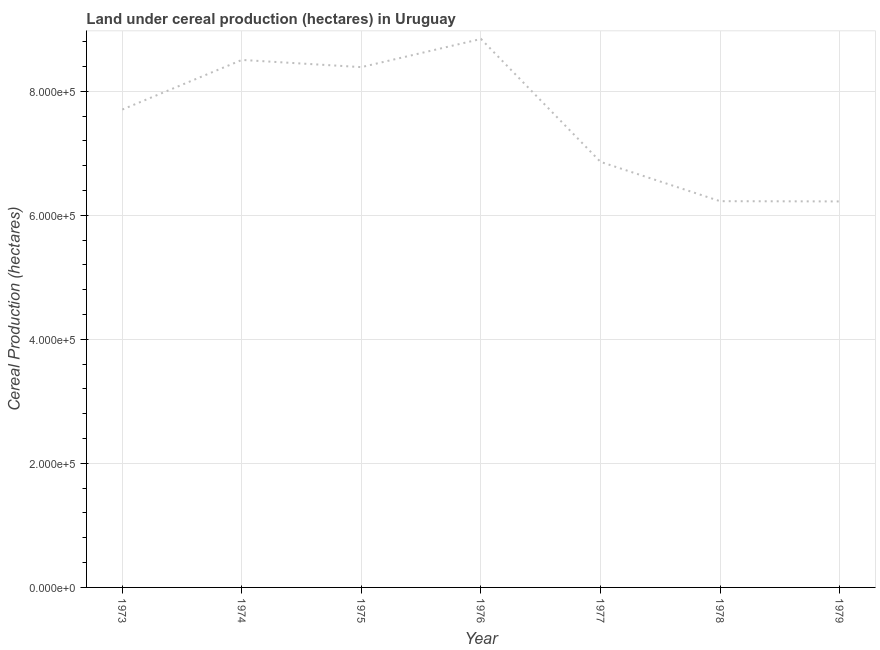What is the land under cereal production in 1979?
Your answer should be compact. 6.22e+05. Across all years, what is the maximum land under cereal production?
Make the answer very short. 8.84e+05. Across all years, what is the minimum land under cereal production?
Make the answer very short. 6.22e+05. In which year was the land under cereal production maximum?
Offer a very short reply. 1976. In which year was the land under cereal production minimum?
Give a very brief answer. 1979. What is the sum of the land under cereal production?
Your answer should be compact. 5.28e+06. What is the difference between the land under cereal production in 1973 and 1976?
Your answer should be very brief. -1.14e+05. What is the average land under cereal production per year?
Your answer should be very brief. 7.54e+05. What is the median land under cereal production?
Offer a terse response. 7.70e+05. Do a majority of the years between 1974 and 1978 (inclusive) have land under cereal production greater than 280000 hectares?
Give a very brief answer. Yes. What is the ratio of the land under cereal production in 1977 to that in 1979?
Your answer should be compact. 1.1. Is the difference between the land under cereal production in 1974 and 1978 greater than the difference between any two years?
Offer a terse response. No. What is the difference between the highest and the second highest land under cereal production?
Your response must be concise. 3.38e+04. What is the difference between the highest and the lowest land under cereal production?
Offer a very short reply. 2.62e+05. In how many years, is the land under cereal production greater than the average land under cereal production taken over all years?
Your response must be concise. 4. What is the difference between two consecutive major ticks on the Y-axis?
Your response must be concise. 2.00e+05. What is the title of the graph?
Offer a very short reply. Land under cereal production (hectares) in Uruguay. What is the label or title of the X-axis?
Offer a terse response. Year. What is the label or title of the Y-axis?
Give a very brief answer. Cereal Production (hectares). What is the Cereal Production (hectares) of 1973?
Provide a short and direct response. 7.70e+05. What is the Cereal Production (hectares) of 1974?
Make the answer very short. 8.50e+05. What is the Cereal Production (hectares) of 1975?
Your answer should be very brief. 8.39e+05. What is the Cereal Production (hectares) in 1976?
Your response must be concise. 8.84e+05. What is the Cereal Production (hectares) of 1977?
Your response must be concise. 6.86e+05. What is the Cereal Production (hectares) of 1978?
Provide a succinct answer. 6.23e+05. What is the Cereal Production (hectares) of 1979?
Make the answer very short. 6.22e+05. What is the difference between the Cereal Production (hectares) in 1973 and 1974?
Provide a succinct answer. -8.00e+04. What is the difference between the Cereal Production (hectares) in 1973 and 1975?
Your answer should be compact. -6.84e+04. What is the difference between the Cereal Production (hectares) in 1973 and 1976?
Ensure brevity in your answer.  -1.14e+05. What is the difference between the Cereal Production (hectares) in 1973 and 1977?
Keep it short and to the point. 8.44e+04. What is the difference between the Cereal Production (hectares) in 1973 and 1978?
Keep it short and to the point. 1.48e+05. What is the difference between the Cereal Production (hectares) in 1973 and 1979?
Offer a terse response. 1.48e+05. What is the difference between the Cereal Production (hectares) in 1974 and 1975?
Your answer should be compact. 1.16e+04. What is the difference between the Cereal Production (hectares) in 1974 and 1976?
Offer a terse response. -3.38e+04. What is the difference between the Cereal Production (hectares) in 1974 and 1977?
Provide a short and direct response. 1.64e+05. What is the difference between the Cereal Production (hectares) in 1974 and 1978?
Give a very brief answer. 2.28e+05. What is the difference between the Cereal Production (hectares) in 1974 and 1979?
Ensure brevity in your answer.  2.28e+05. What is the difference between the Cereal Production (hectares) in 1975 and 1976?
Offer a very short reply. -4.54e+04. What is the difference between the Cereal Production (hectares) in 1975 and 1977?
Provide a succinct answer. 1.53e+05. What is the difference between the Cereal Production (hectares) in 1975 and 1978?
Provide a succinct answer. 2.16e+05. What is the difference between the Cereal Production (hectares) in 1975 and 1979?
Provide a succinct answer. 2.17e+05. What is the difference between the Cereal Production (hectares) in 1976 and 1977?
Offer a terse response. 1.98e+05. What is the difference between the Cereal Production (hectares) in 1976 and 1978?
Your answer should be very brief. 2.62e+05. What is the difference between the Cereal Production (hectares) in 1976 and 1979?
Your response must be concise. 2.62e+05. What is the difference between the Cereal Production (hectares) in 1977 and 1978?
Your answer should be very brief. 6.34e+04. What is the difference between the Cereal Production (hectares) in 1977 and 1979?
Keep it short and to the point. 6.38e+04. What is the difference between the Cereal Production (hectares) in 1978 and 1979?
Offer a terse response. 376. What is the ratio of the Cereal Production (hectares) in 1973 to that in 1974?
Your response must be concise. 0.91. What is the ratio of the Cereal Production (hectares) in 1973 to that in 1975?
Your answer should be very brief. 0.92. What is the ratio of the Cereal Production (hectares) in 1973 to that in 1976?
Offer a terse response. 0.87. What is the ratio of the Cereal Production (hectares) in 1973 to that in 1977?
Give a very brief answer. 1.12. What is the ratio of the Cereal Production (hectares) in 1973 to that in 1978?
Your answer should be very brief. 1.24. What is the ratio of the Cereal Production (hectares) in 1973 to that in 1979?
Your answer should be very brief. 1.24. What is the ratio of the Cereal Production (hectares) in 1974 to that in 1977?
Your response must be concise. 1.24. What is the ratio of the Cereal Production (hectares) in 1974 to that in 1978?
Ensure brevity in your answer.  1.37. What is the ratio of the Cereal Production (hectares) in 1974 to that in 1979?
Your answer should be very brief. 1.37. What is the ratio of the Cereal Production (hectares) in 1975 to that in 1976?
Provide a succinct answer. 0.95. What is the ratio of the Cereal Production (hectares) in 1975 to that in 1977?
Keep it short and to the point. 1.22. What is the ratio of the Cereal Production (hectares) in 1975 to that in 1978?
Make the answer very short. 1.35. What is the ratio of the Cereal Production (hectares) in 1975 to that in 1979?
Your answer should be compact. 1.35. What is the ratio of the Cereal Production (hectares) in 1976 to that in 1977?
Keep it short and to the point. 1.29. What is the ratio of the Cereal Production (hectares) in 1976 to that in 1978?
Provide a short and direct response. 1.42. What is the ratio of the Cereal Production (hectares) in 1976 to that in 1979?
Your answer should be compact. 1.42. What is the ratio of the Cereal Production (hectares) in 1977 to that in 1978?
Provide a succinct answer. 1.1. What is the ratio of the Cereal Production (hectares) in 1977 to that in 1979?
Ensure brevity in your answer.  1.1. 